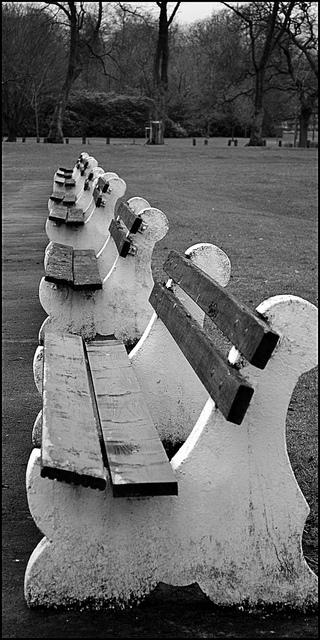What is the color scheme?
Give a very brief answer. Black and white. What are the benches made of?
Concise answer only. Wood. What is the bench made of?
Concise answer only. Wood. How many benches have people sitting on them?
Quick response, please. 0. 